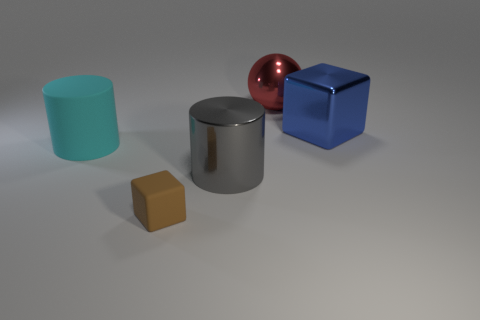Add 4 brown matte objects. How many objects exist? 9 Subtract all balls. How many objects are left? 4 Add 2 large cyan rubber cylinders. How many large cyan rubber cylinders are left? 3 Add 1 big blocks. How many big blocks exist? 2 Subtract 0 red cubes. How many objects are left? 5 Subtract all tiny green shiny things. Subtract all large shiny cylinders. How many objects are left? 4 